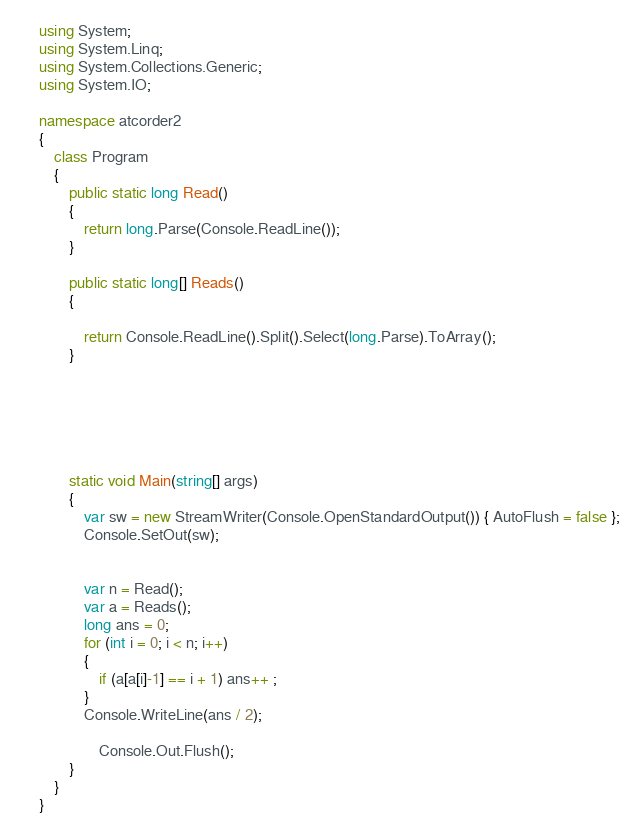<code> <loc_0><loc_0><loc_500><loc_500><_C#_>using System;
using System.Linq;
using System.Collections.Generic;
using System.IO;

namespace atcorder2
{
    class Program
    {
        public static long Read()
        {
            return long.Parse(Console.ReadLine());
        }

        public static long[] Reads()
        {

            return Console.ReadLine().Split().Select(long.Parse).ToArray();
        }






        static void Main(string[] args)
        {
            var sw = new StreamWriter(Console.OpenStandardOutput()) { AutoFlush = false };
            Console.SetOut(sw);


            var n = Read();
            var a = Reads();
            long ans = 0;
            for (int i = 0; i < n; i++)
            {
                if (a[a[i]-1] == i + 1) ans++ ;
            }
            Console.WriteLine(ans / 2);

                Console.Out.Flush();
        }
    }
}


</code> 